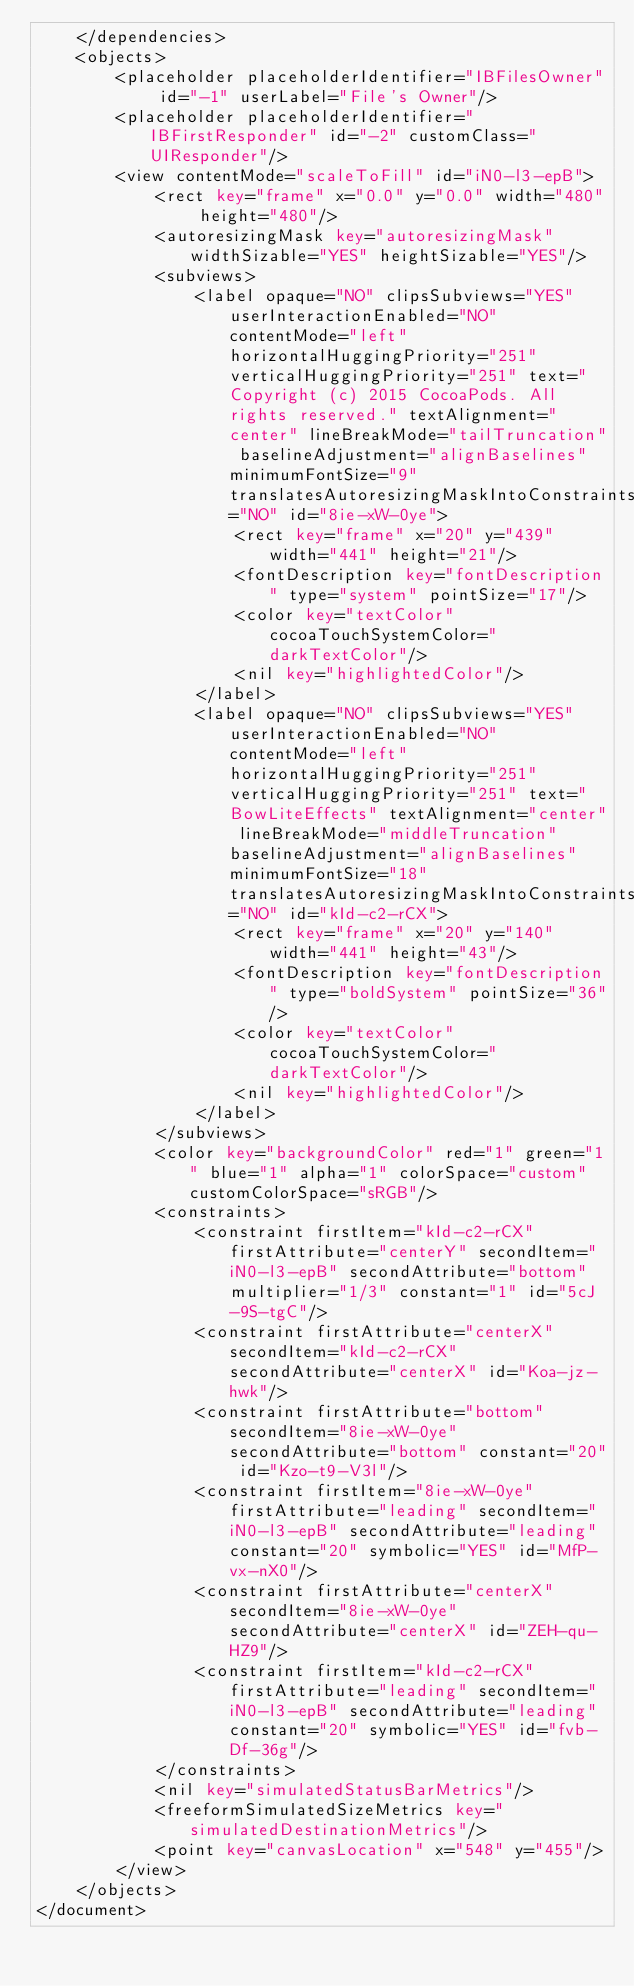<code> <loc_0><loc_0><loc_500><loc_500><_XML_>    </dependencies>
    <objects>
        <placeholder placeholderIdentifier="IBFilesOwner" id="-1" userLabel="File's Owner"/>
        <placeholder placeholderIdentifier="IBFirstResponder" id="-2" customClass="UIResponder"/>
        <view contentMode="scaleToFill" id="iN0-l3-epB">
            <rect key="frame" x="0.0" y="0.0" width="480" height="480"/>
            <autoresizingMask key="autoresizingMask" widthSizable="YES" heightSizable="YES"/>
            <subviews>
                <label opaque="NO" clipsSubviews="YES" userInteractionEnabled="NO" contentMode="left" horizontalHuggingPriority="251" verticalHuggingPriority="251" text="  Copyright (c) 2015 CocoaPods. All rights reserved." textAlignment="center" lineBreakMode="tailTruncation" baselineAdjustment="alignBaselines" minimumFontSize="9" translatesAutoresizingMaskIntoConstraints="NO" id="8ie-xW-0ye">
                    <rect key="frame" x="20" y="439" width="441" height="21"/>
                    <fontDescription key="fontDescription" type="system" pointSize="17"/>
                    <color key="textColor" cocoaTouchSystemColor="darkTextColor"/>
                    <nil key="highlightedColor"/>
                </label>
                <label opaque="NO" clipsSubviews="YES" userInteractionEnabled="NO" contentMode="left" horizontalHuggingPriority="251" verticalHuggingPriority="251" text="BowLiteEffects" textAlignment="center" lineBreakMode="middleTruncation" baselineAdjustment="alignBaselines" minimumFontSize="18" translatesAutoresizingMaskIntoConstraints="NO" id="kId-c2-rCX">
                    <rect key="frame" x="20" y="140" width="441" height="43"/>
                    <fontDescription key="fontDescription" type="boldSystem" pointSize="36"/>
                    <color key="textColor" cocoaTouchSystemColor="darkTextColor"/>
                    <nil key="highlightedColor"/>
                </label>
            </subviews>
            <color key="backgroundColor" red="1" green="1" blue="1" alpha="1" colorSpace="custom" customColorSpace="sRGB"/>
            <constraints>
                <constraint firstItem="kId-c2-rCX" firstAttribute="centerY" secondItem="iN0-l3-epB" secondAttribute="bottom" multiplier="1/3" constant="1" id="5cJ-9S-tgC"/>
                <constraint firstAttribute="centerX" secondItem="kId-c2-rCX" secondAttribute="centerX" id="Koa-jz-hwk"/>
                <constraint firstAttribute="bottom" secondItem="8ie-xW-0ye" secondAttribute="bottom" constant="20" id="Kzo-t9-V3l"/>
                <constraint firstItem="8ie-xW-0ye" firstAttribute="leading" secondItem="iN0-l3-epB" secondAttribute="leading" constant="20" symbolic="YES" id="MfP-vx-nX0"/>
                <constraint firstAttribute="centerX" secondItem="8ie-xW-0ye" secondAttribute="centerX" id="ZEH-qu-HZ9"/>
                <constraint firstItem="kId-c2-rCX" firstAttribute="leading" secondItem="iN0-l3-epB" secondAttribute="leading" constant="20" symbolic="YES" id="fvb-Df-36g"/>
            </constraints>
            <nil key="simulatedStatusBarMetrics"/>
            <freeformSimulatedSizeMetrics key="simulatedDestinationMetrics"/>
            <point key="canvasLocation" x="548" y="455"/>
        </view>
    </objects>
</document>
</code> 